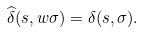<formula> <loc_0><loc_0><loc_500><loc_500>\widehat { \delta } ( s , w \sigma ) = \delta ( s , \sigma ) .</formula> 